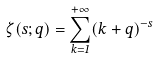<formula> <loc_0><loc_0><loc_500><loc_500>\zeta ( s ; q ) = \sum _ { k = 1 } ^ { + \infty } ( k + q ) ^ { - s }</formula> 